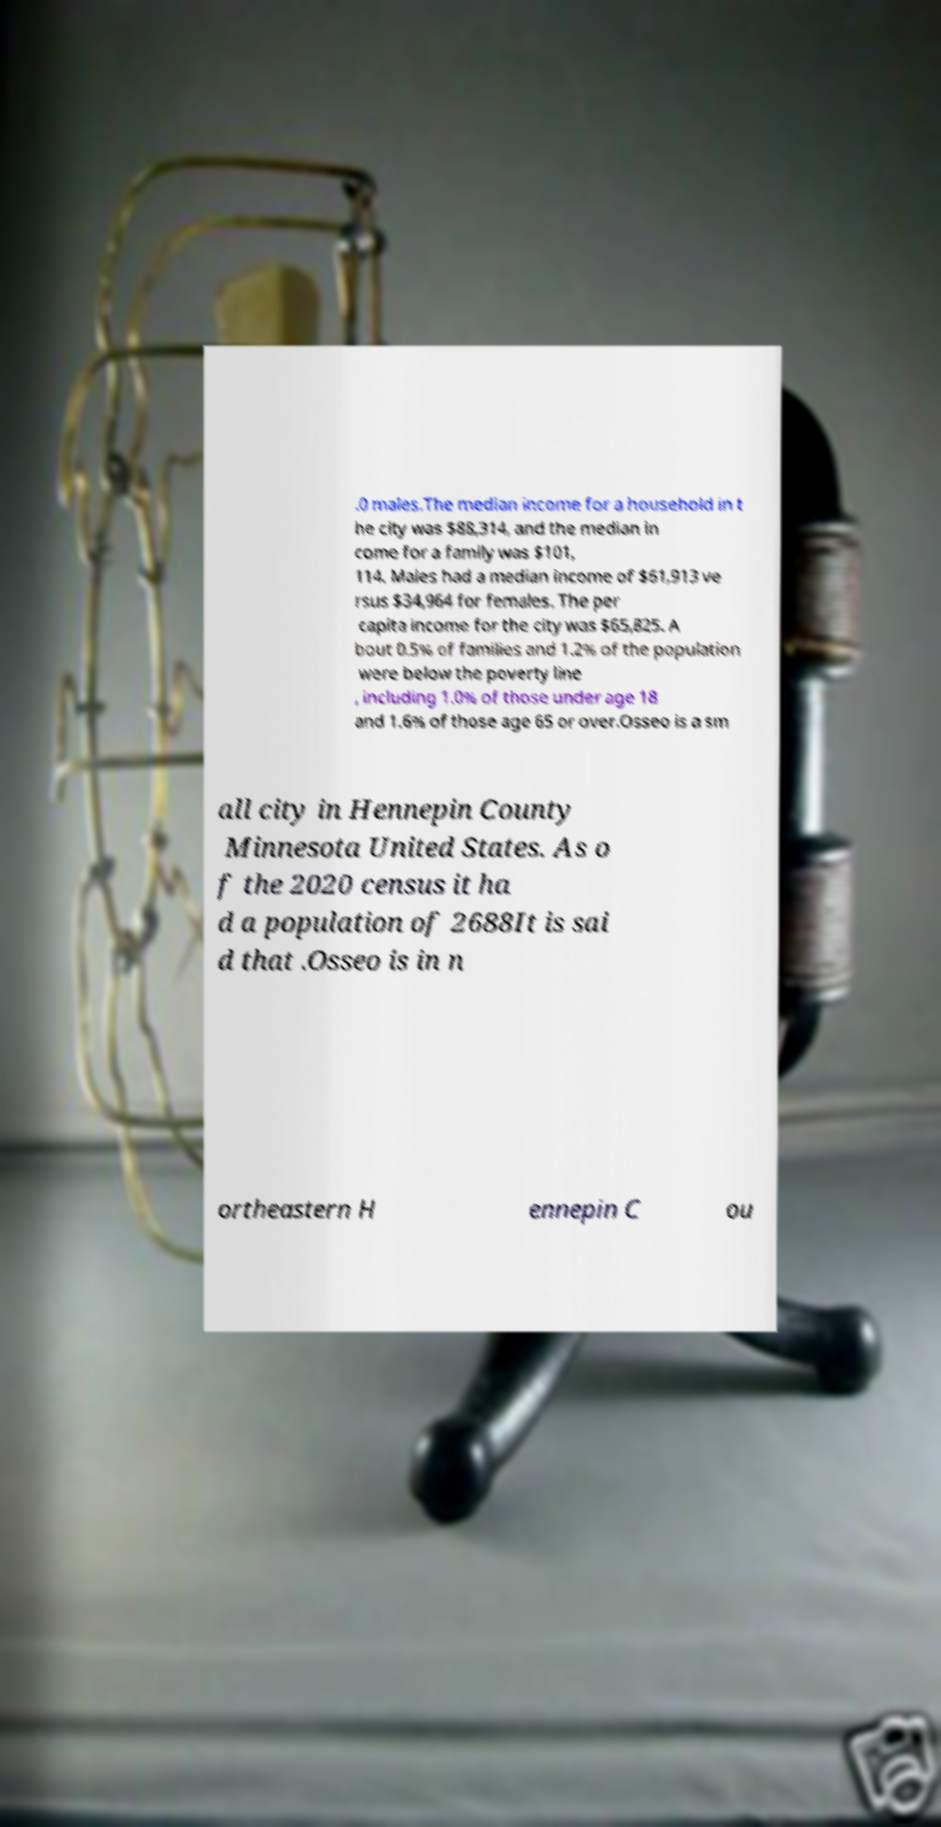Could you extract and type out the text from this image? .0 males.The median income for a household in t he city was $88,314, and the median in come for a family was $101, 114. Males had a median income of $61,913 ve rsus $34,964 for females. The per capita income for the city was $65,825. A bout 0.5% of families and 1.2% of the population were below the poverty line , including 1.0% of those under age 18 and 1.6% of those age 65 or over.Osseo is a sm all city in Hennepin County Minnesota United States. As o f the 2020 census it ha d a population of 2688It is sai d that .Osseo is in n ortheastern H ennepin C ou 